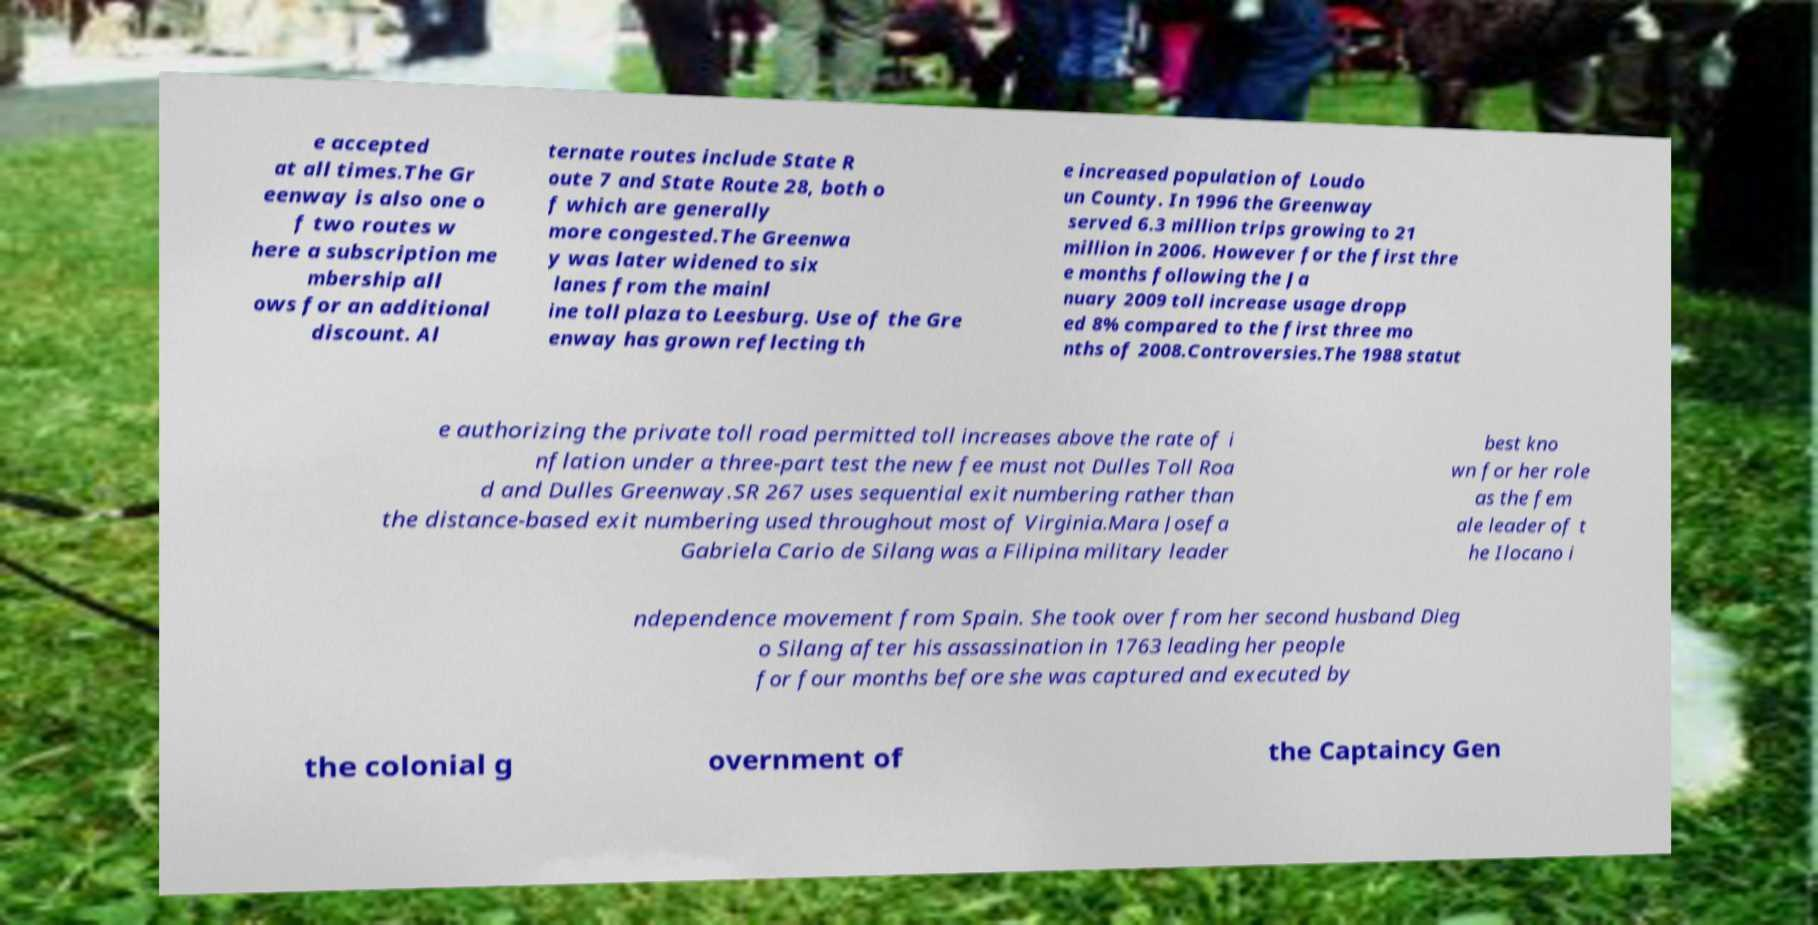Could you extract and type out the text from this image? e accepted at all times.The Gr eenway is also one o f two routes w here a subscription me mbership all ows for an additional discount. Al ternate routes include State R oute 7 and State Route 28, both o f which are generally more congested.The Greenwa y was later widened to six lanes from the mainl ine toll plaza to Leesburg. Use of the Gre enway has grown reflecting th e increased population of Loudo un County. In 1996 the Greenway served 6.3 million trips growing to 21 million in 2006. However for the first thre e months following the Ja nuary 2009 toll increase usage dropp ed 8% compared to the first three mo nths of 2008.Controversies.The 1988 statut e authorizing the private toll road permitted toll increases above the rate of i nflation under a three-part test the new fee must not Dulles Toll Roa d and Dulles Greenway.SR 267 uses sequential exit numbering rather than the distance-based exit numbering used throughout most of Virginia.Mara Josefa Gabriela Cario de Silang was a Filipina military leader best kno wn for her role as the fem ale leader of t he Ilocano i ndependence movement from Spain. She took over from her second husband Dieg o Silang after his assassination in 1763 leading her people for four months before she was captured and executed by the colonial g overnment of the Captaincy Gen 